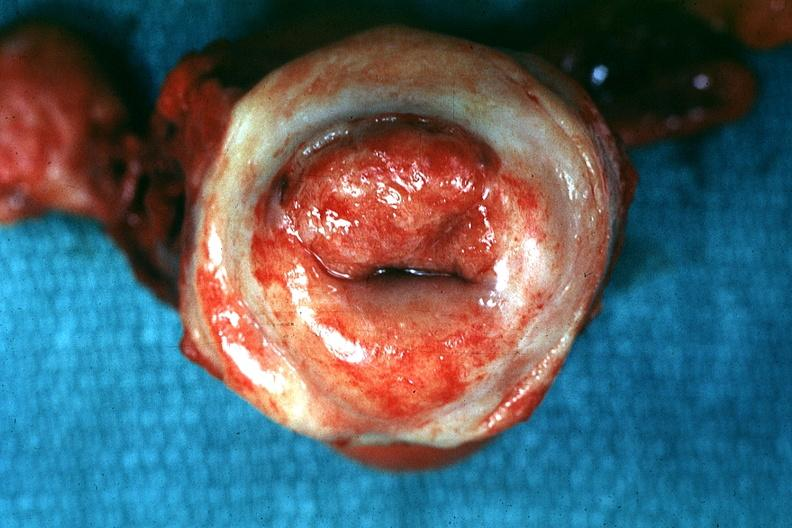does this image show excellent close-up of thickened?
Answer the question using a single word or phrase. Yes 